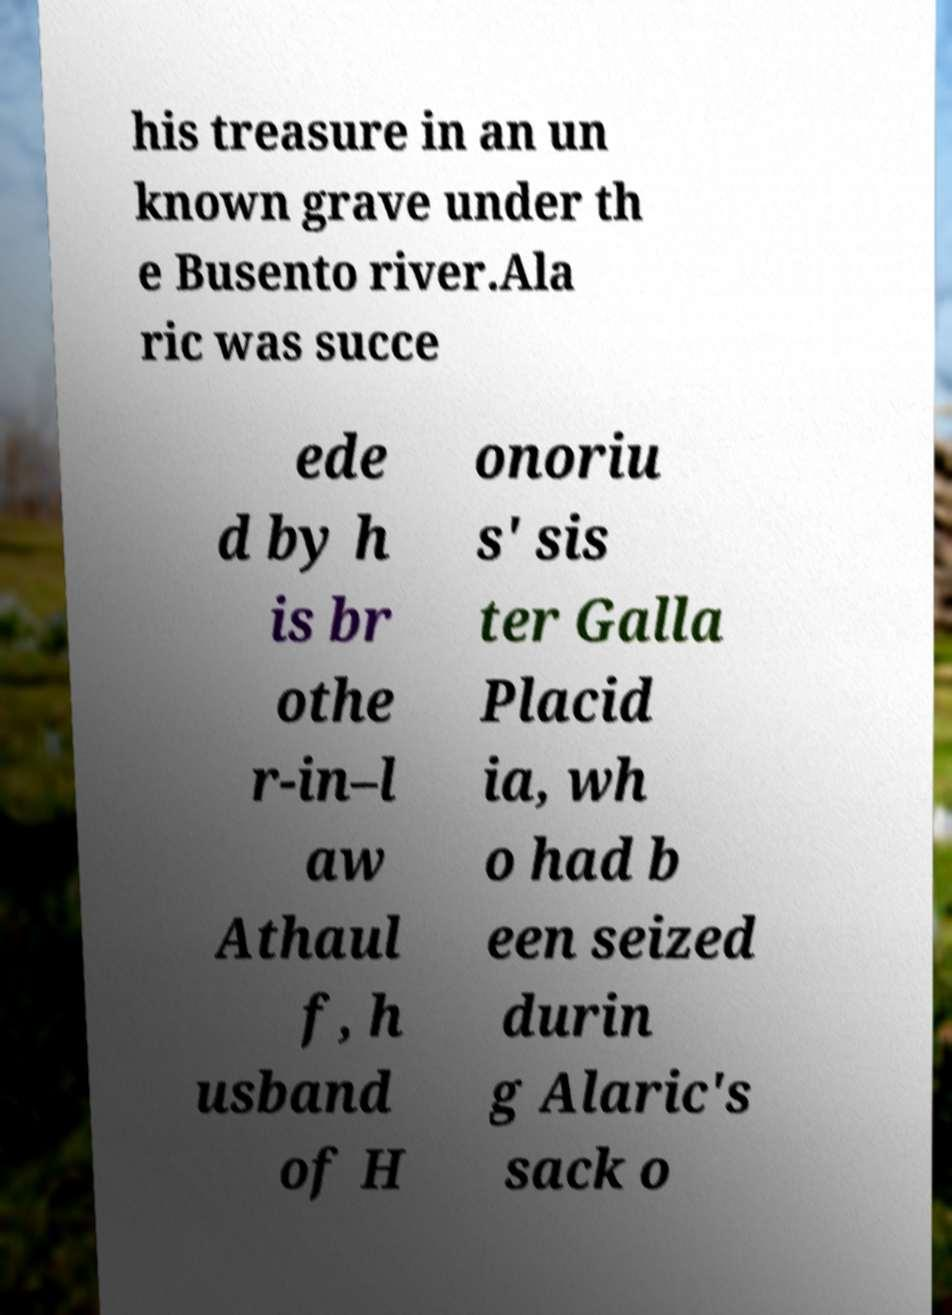I need the written content from this picture converted into text. Can you do that? his treasure in an un known grave under th e Busento river.Ala ric was succe ede d by h is br othe r-in–l aw Athaul f, h usband of H onoriu s' sis ter Galla Placid ia, wh o had b een seized durin g Alaric's sack o 